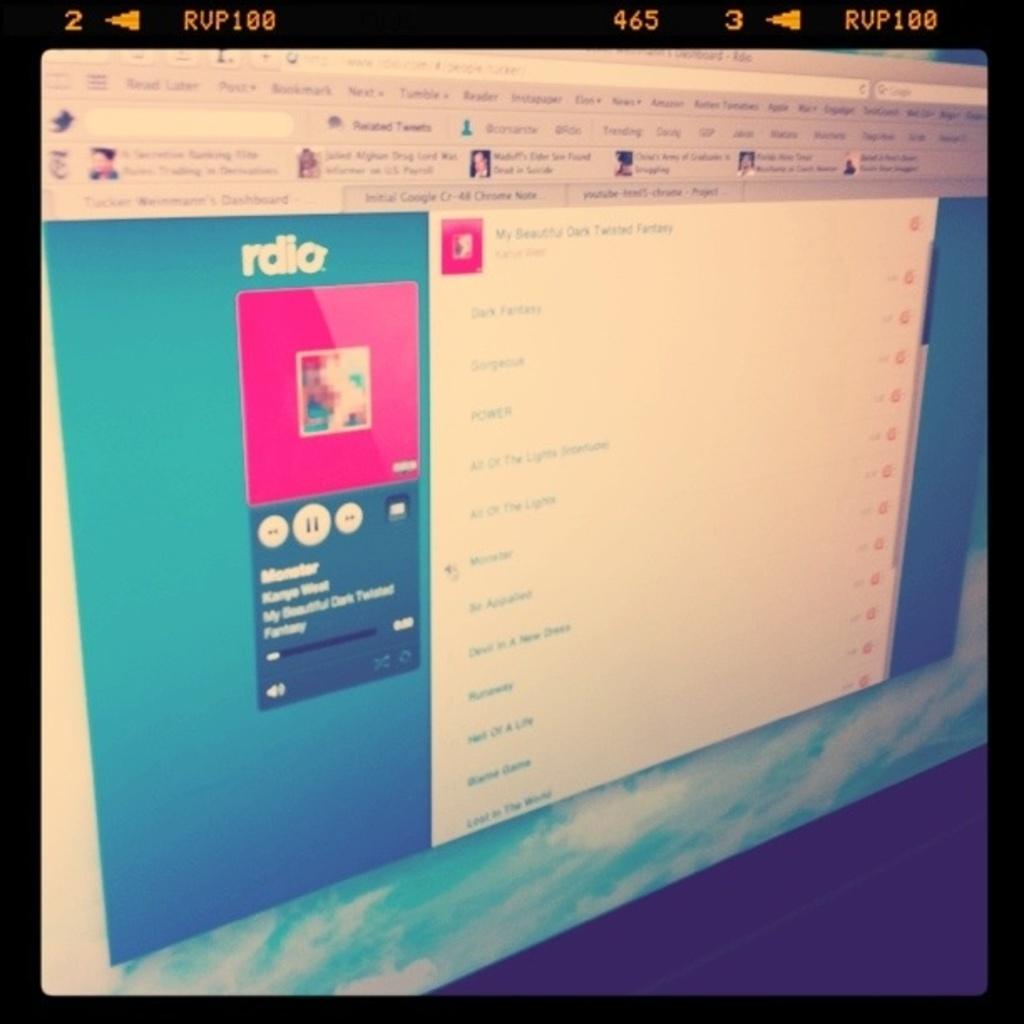What website is open?
Provide a succinct answer. Rdio. What are they listening to?
Give a very brief answer. Rdio. 